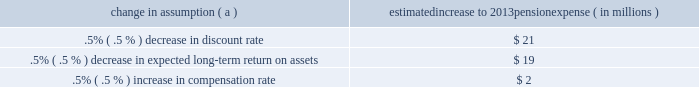Securities have historically returned approximately 10% ( 10 % ) annually over long periods of time , while u.s .
Debt securities have returned approximately 6% ( 6 % ) annually over long periods .
Application of these historical returns to the plan 2019s allocation ranges for equities and bonds produces a result between 7.25% ( 7.25 % ) and 8.75% ( 8.75 % ) and is one point of reference , among many other factors , that is taken into consideration .
We also examine the plan 2019s actual historical returns over various periods and consider the current economic environment .
Recent experience is considered in our evaluation with appropriate consideration that , especially for short time periods , recent returns are not reliable indicators of future returns .
While annual returns can vary significantly ( actual returns for 2012 , 2011 , and 2010 were +15.29% ( +15.29 % ) , +.11% ( +.11 % ) , and +14.87% ( +14.87 % ) , respectively ) , the selected assumption represents our estimated long-term average prospective returns .
Acknowledging the potentially wide range for this assumption , we also annually examine the assumption used by other companies with similar pension investment strategies , so that we can ascertain whether our determinations markedly differ from others .
In all cases , however , this data simply informs our process , which places the greatest emphasis on our qualitative judgment of future investment returns , given the conditions existing at each annual measurement date .
Taking into consideration all of these factors , the expected long-term return on plan assets for determining net periodic pension cost for 2012 was 7.75% ( 7.75 % ) , the same as it was for 2011 .
After considering the views of both internal and external capital market advisors , particularly with regard to the effects of the recent economic environment on long-term prospective fixed income returns , we are reducing our expected long-term return on assets to 7.50% ( 7.50 % ) for determining pension cost for under current accounting rules , the difference between expected long-term returns and actual returns is accumulated and amortized to pension expense over future periods .
Each one percentage point difference in actual return compared with our expected return causes expense in subsequent years to increase or decrease by up to $ 8 million as the impact is amortized into results of operations .
We currently estimate a pretax pension expense of $ 73 million in 2013 compared with pretax expense of $ 89 million in 2012 .
This year-over-year expected decrease reflects the impact of favorable returns on plan assets experienced in 2012 as well as the effects of the lower discount rate required to be used in the table below reflects the estimated effects on pension expense of certain changes in annual assumptions , using 2013 estimated expense as a baseline .
Table 27 : pension expense - sensitivity analysis change in assumption ( a ) estimated increase to 2013 pension expense ( in millions ) .
( a ) the impact is the effect of changing the specified assumption while holding all other assumptions constant .
Our pension plan contribution requirements are not particularly sensitive to actuarial assumptions .
Investment performance has the most impact on contribution requirements and will drive the amount of required contributions in future years .
Also , current law , including the provisions of the pension protection act of 2006 , sets limits as to both minimum and maximum contributions to the plan .
We do not expect to be required by law to make any contributions to the plan during 2013 .
We maintain other defined benefit plans that have a less significant effect on financial results , including various nonqualified supplemental retirement plans for certain employees , which are described more fully in note 15 employee benefit plans in the notes to consolidated financial statements in item 8 of this report .
The pnc financial services group , inc .
2013 form 10-k 77 .
By what percentage did the pension pretax expenses decrease from 2012 to 2013? 
Computations: (((89 - 73) / 89) * 100)
Answer: 17.97753. Securities have historically returned approximately 10% ( 10 % ) annually over long periods of time , while u.s .
Debt securities have returned approximately 6% ( 6 % ) annually over long periods .
Application of these historical returns to the plan 2019s allocation ranges for equities and bonds produces a result between 7.25% ( 7.25 % ) and 8.75% ( 8.75 % ) and is one point of reference , among many other factors , that is taken into consideration .
We also examine the plan 2019s actual historical returns over various periods and consider the current economic environment .
Recent experience is considered in our evaluation with appropriate consideration that , especially for short time periods , recent returns are not reliable indicators of future returns .
While annual returns can vary significantly ( actual returns for 2012 , 2011 , and 2010 were +15.29% ( +15.29 % ) , +.11% ( +.11 % ) , and +14.87% ( +14.87 % ) , respectively ) , the selected assumption represents our estimated long-term average prospective returns .
Acknowledging the potentially wide range for this assumption , we also annually examine the assumption used by other companies with similar pension investment strategies , so that we can ascertain whether our determinations markedly differ from others .
In all cases , however , this data simply informs our process , which places the greatest emphasis on our qualitative judgment of future investment returns , given the conditions existing at each annual measurement date .
Taking into consideration all of these factors , the expected long-term return on plan assets for determining net periodic pension cost for 2012 was 7.75% ( 7.75 % ) , the same as it was for 2011 .
After considering the views of both internal and external capital market advisors , particularly with regard to the effects of the recent economic environment on long-term prospective fixed income returns , we are reducing our expected long-term return on assets to 7.50% ( 7.50 % ) for determining pension cost for under current accounting rules , the difference between expected long-term returns and actual returns is accumulated and amortized to pension expense over future periods .
Each one percentage point difference in actual return compared with our expected return causes expense in subsequent years to increase or decrease by up to $ 8 million as the impact is amortized into results of operations .
We currently estimate a pretax pension expense of $ 73 million in 2013 compared with pretax expense of $ 89 million in 2012 .
This year-over-year expected decrease reflects the impact of favorable returns on plan assets experienced in 2012 as well as the effects of the lower discount rate required to be used in the table below reflects the estimated effects on pension expense of certain changes in annual assumptions , using 2013 estimated expense as a baseline .
Table 27 : pension expense - sensitivity analysis change in assumption ( a ) estimated increase to 2013 pension expense ( in millions ) .
( a ) the impact is the effect of changing the specified assumption while holding all other assumptions constant .
Our pension plan contribution requirements are not particularly sensitive to actuarial assumptions .
Investment performance has the most impact on contribution requirements and will drive the amount of required contributions in future years .
Also , current law , including the provisions of the pension protection act of 2006 , sets limits as to both minimum and maximum contributions to the plan .
We do not expect to be required by law to make any contributions to the plan during 2013 .
We maintain other defined benefit plans that have a less significant effect on financial results , including various nonqualified supplemental retirement plans for certain employees , which are described more fully in note 15 employee benefit plans in the notes to consolidated financial statements in item 8 of this report .
The pnc financial services group , inc .
2013 form 10-k 77 .
By what percentage did the pension pretax expenses decrease from 2012 to 2013? 
Computations: (((89 - 73) / 89) * 100)
Answer: 17.97753. 